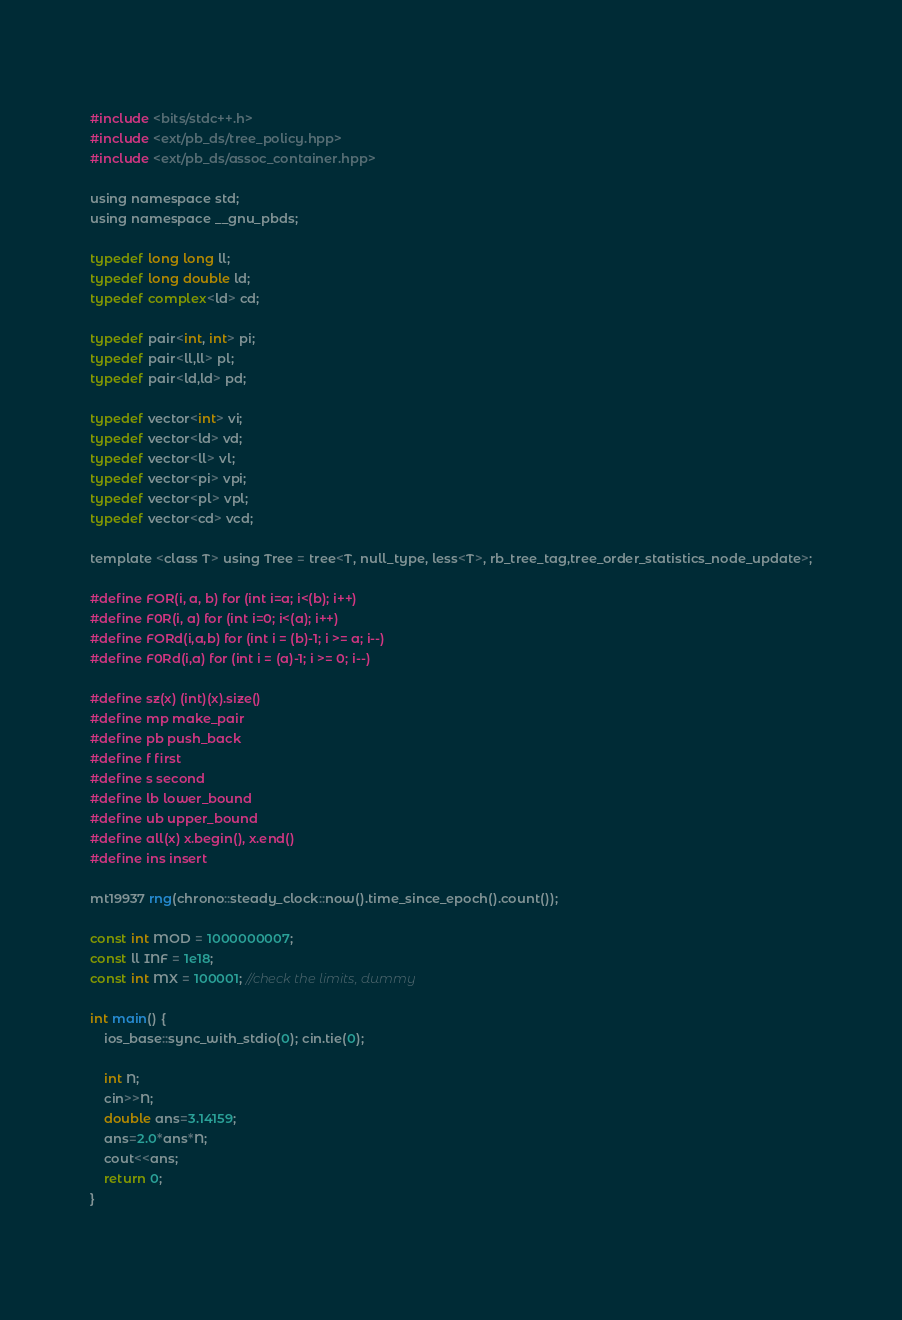Convert code to text. <code><loc_0><loc_0><loc_500><loc_500><_C_> 
#include <bits/stdc++.h>
#include <ext/pb_ds/tree_policy.hpp>
#include <ext/pb_ds/assoc_container.hpp>
 
using namespace std;
using namespace __gnu_pbds;
 
typedef long long ll;
typedef long double ld;
typedef complex<ld> cd;
 
typedef pair<int, int> pi;
typedef pair<ll,ll> pl;
typedef pair<ld,ld> pd;
 
typedef vector<int> vi;
typedef vector<ld> vd;
typedef vector<ll> vl;
typedef vector<pi> vpi;
typedef vector<pl> vpl;
typedef vector<cd> vcd;
 
template <class T> using Tree = tree<T, null_type, less<T>, rb_tree_tag,tree_order_statistics_node_update>;
 
#define FOR(i, a, b) for (int i=a; i<(b); i++)
#define F0R(i, a) for (int i=0; i<(a); i++)
#define FORd(i,a,b) for (int i = (b)-1; i >= a; i--)
#define F0Rd(i,a) for (int i = (a)-1; i >= 0; i--)
 
#define sz(x) (int)(x).size()
#define mp make_pair
#define pb push_back
#define f first
#define s second
#define lb lower_bound
#define ub upper_bound
#define all(x) x.begin(), x.end()
#define ins insert
 
mt19937 rng(chrono::steady_clock::now().time_since_epoch().count());
 
const int MOD = 1000000007;
const ll INF = 1e18;
const int MX = 100001; //check the limits, dummy
 
int main() {
	ios_base::sync_with_stdio(0); cin.tie(0);    
	
    int N;
    cin>>N;
    double ans=3.14159;
    ans=2.0*ans*N;
    cout<<ans;	
	return 0;
}
 
</code> 